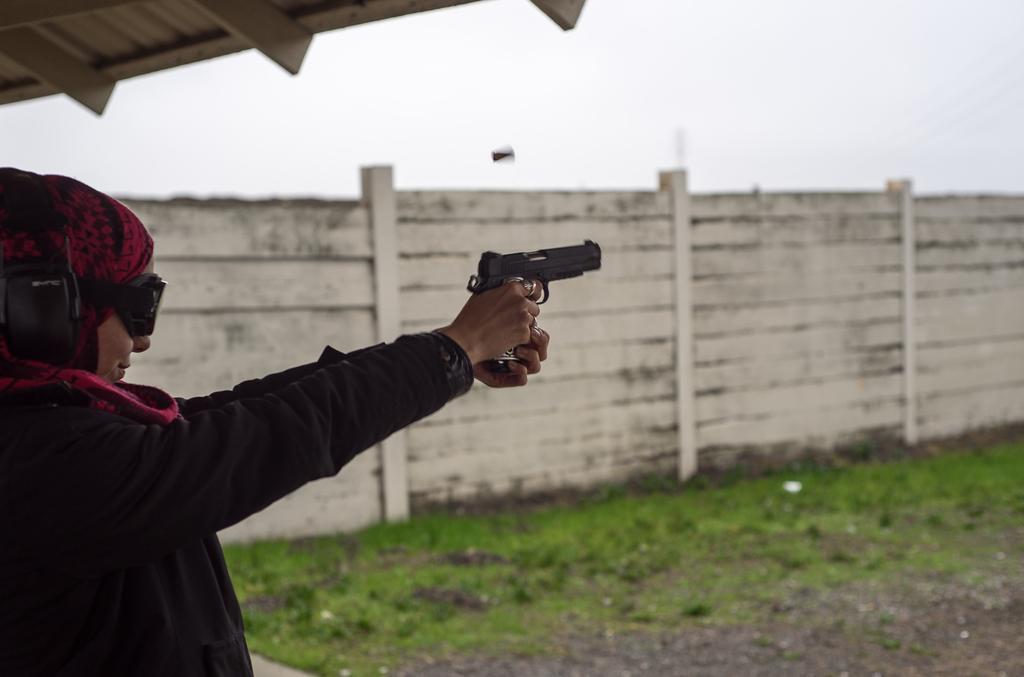Describe this image in one or two sentences. In this picture there is a person standing and holding the gun. At the back there is a wall. At the top there is sky and there is a roof. At the bottom there is grass and there is ground. 